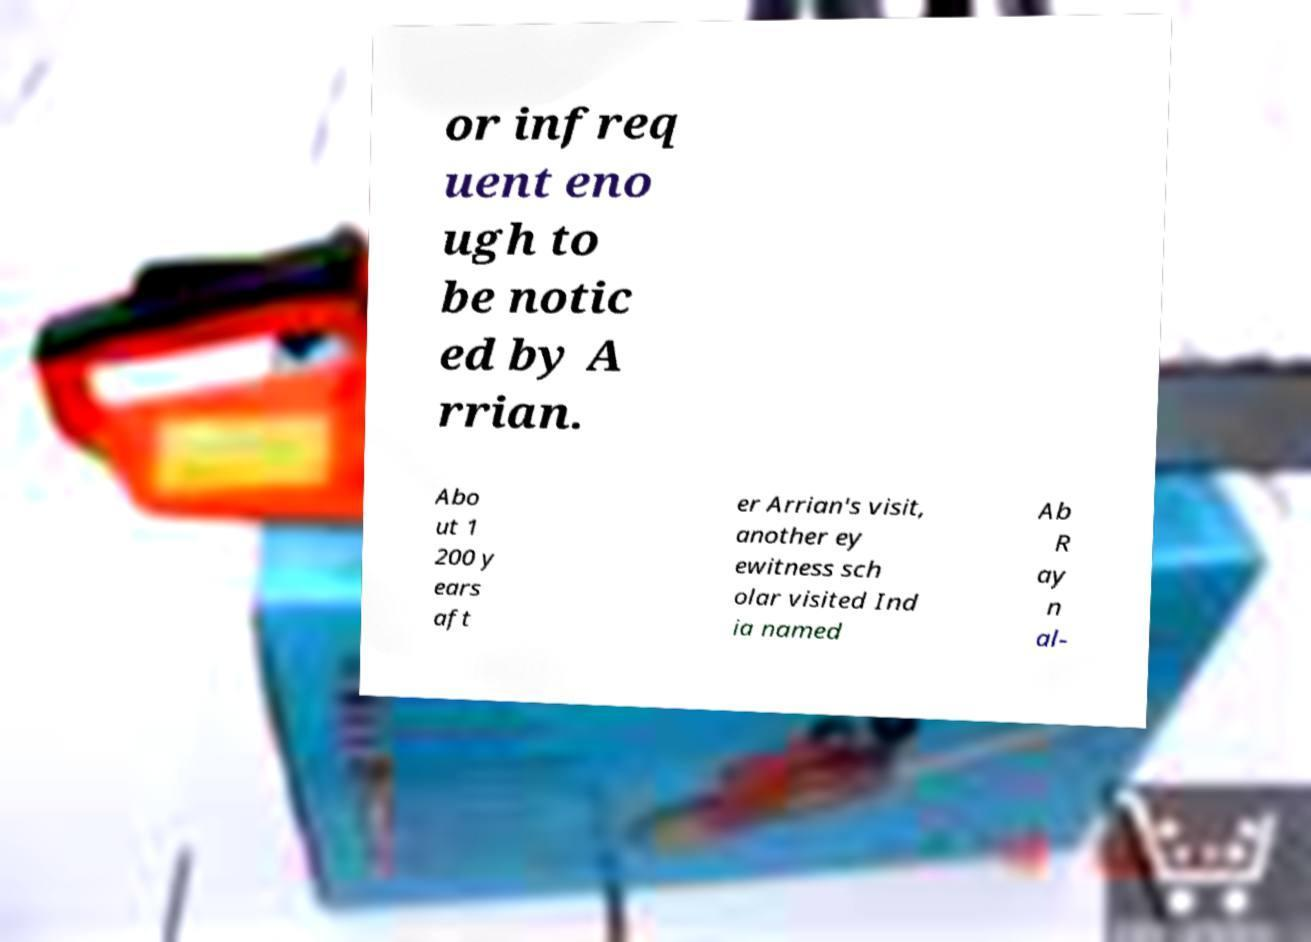There's text embedded in this image that I need extracted. Can you transcribe it verbatim? or infreq uent eno ugh to be notic ed by A rrian. Abo ut 1 200 y ears aft er Arrian's visit, another ey ewitness sch olar visited Ind ia named Ab R ay n al- 